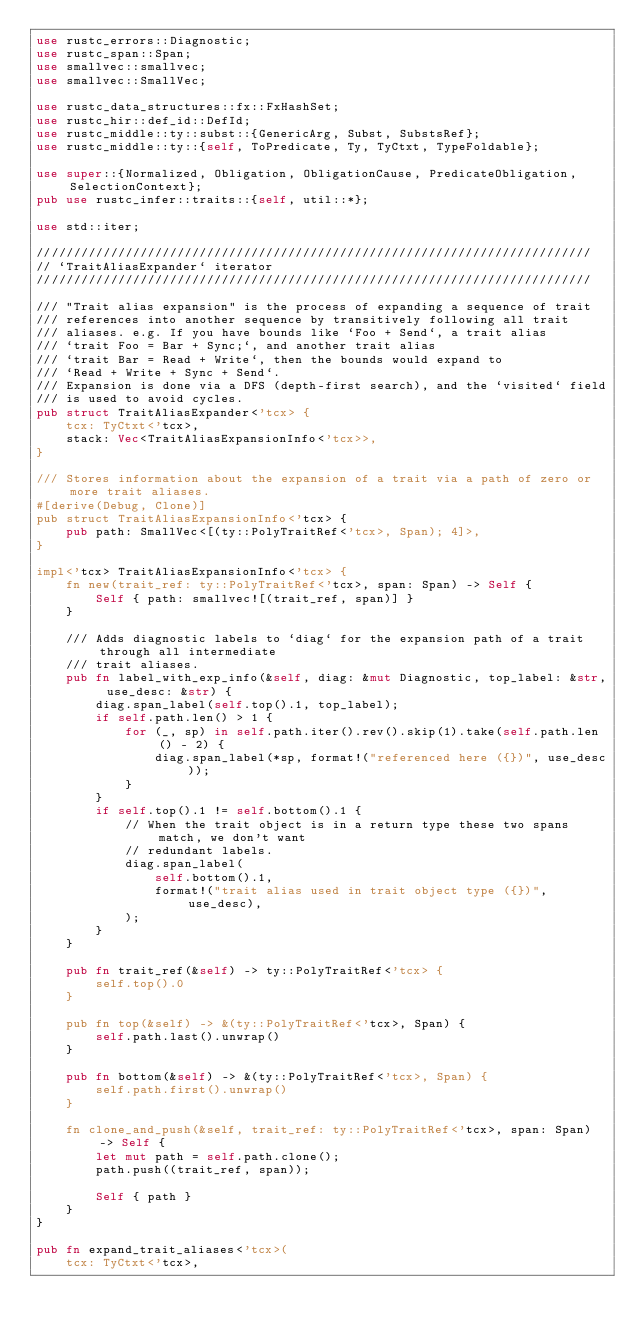<code> <loc_0><loc_0><loc_500><loc_500><_Rust_>use rustc_errors::Diagnostic;
use rustc_span::Span;
use smallvec::smallvec;
use smallvec::SmallVec;

use rustc_data_structures::fx::FxHashSet;
use rustc_hir::def_id::DefId;
use rustc_middle::ty::subst::{GenericArg, Subst, SubstsRef};
use rustc_middle::ty::{self, ToPredicate, Ty, TyCtxt, TypeFoldable};

use super::{Normalized, Obligation, ObligationCause, PredicateObligation, SelectionContext};
pub use rustc_infer::traits::{self, util::*};

use std::iter;

///////////////////////////////////////////////////////////////////////////
// `TraitAliasExpander` iterator
///////////////////////////////////////////////////////////////////////////

/// "Trait alias expansion" is the process of expanding a sequence of trait
/// references into another sequence by transitively following all trait
/// aliases. e.g. If you have bounds like `Foo + Send`, a trait alias
/// `trait Foo = Bar + Sync;`, and another trait alias
/// `trait Bar = Read + Write`, then the bounds would expand to
/// `Read + Write + Sync + Send`.
/// Expansion is done via a DFS (depth-first search), and the `visited` field
/// is used to avoid cycles.
pub struct TraitAliasExpander<'tcx> {
    tcx: TyCtxt<'tcx>,
    stack: Vec<TraitAliasExpansionInfo<'tcx>>,
}

/// Stores information about the expansion of a trait via a path of zero or more trait aliases.
#[derive(Debug, Clone)]
pub struct TraitAliasExpansionInfo<'tcx> {
    pub path: SmallVec<[(ty::PolyTraitRef<'tcx>, Span); 4]>,
}

impl<'tcx> TraitAliasExpansionInfo<'tcx> {
    fn new(trait_ref: ty::PolyTraitRef<'tcx>, span: Span) -> Self {
        Self { path: smallvec![(trait_ref, span)] }
    }

    /// Adds diagnostic labels to `diag` for the expansion path of a trait through all intermediate
    /// trait aliases.
    pub fn label_with_exp_info(&self, diag: &mut Diagnostic, top_label: &str, use_desc: &str) {
        diag.span_label(self.top().1, top_label);
        if self.path.len() > 1 {
            for (_, sp) in self.path.iter().rev().skip(1).take(self.path.len() - 2) {
                diag.span_label(*sp, format!("referenced here ({})", use_desc));
            }
        }
        if self.top().1 != self.bottom().1 {
            // When the trait object is in a return type these two spans match, we don't want
            // redundant labels.
            diag.span_label(
                self.bottom().1,
                format!("trait alias used in trait object type ({})", use_desc),
            );
        }
    }

    pub fn trait_ref(&self) -> ty::PolyTraitRef<'tcx> {
        self.top().0
    }

    pub fn top(&self) -> &(ty::PolyTraitRef<'tcx>, Span) {
        self.path.last().unwrap()
    }

    pub fn bottom(&self) -> &(ty::PolyTraitRef<'tcx>, Span) {
        self.path.first().unwrap()
    }

    fn clone_and_push(&self, trait_ref: ty::PolyTraitRef<'tcx>, span: Span) -> Self {
        let mut path = self.path.clone();
        path.push((trait_ref, span));

        Self { path }
    }
}

pub fn expand_trait_aliases<'tcx>(
    tcx: TyCtxt<'tcx>,</code> 